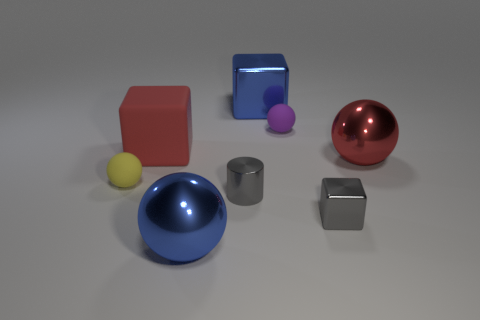Add 2 tiny gray blocks. How many objects exist? 10 Subtract all cubes. How many objects are left? 5 Subtract 1 blue cubes. How many objects are left? 7 Subtract all large red rubber spheres. Subtract all blue metallic objects. How many objects are left? 6 Add 8 big balls. How many big balls are left? 10 Add 5 gray things. How many gray things exist? 7 